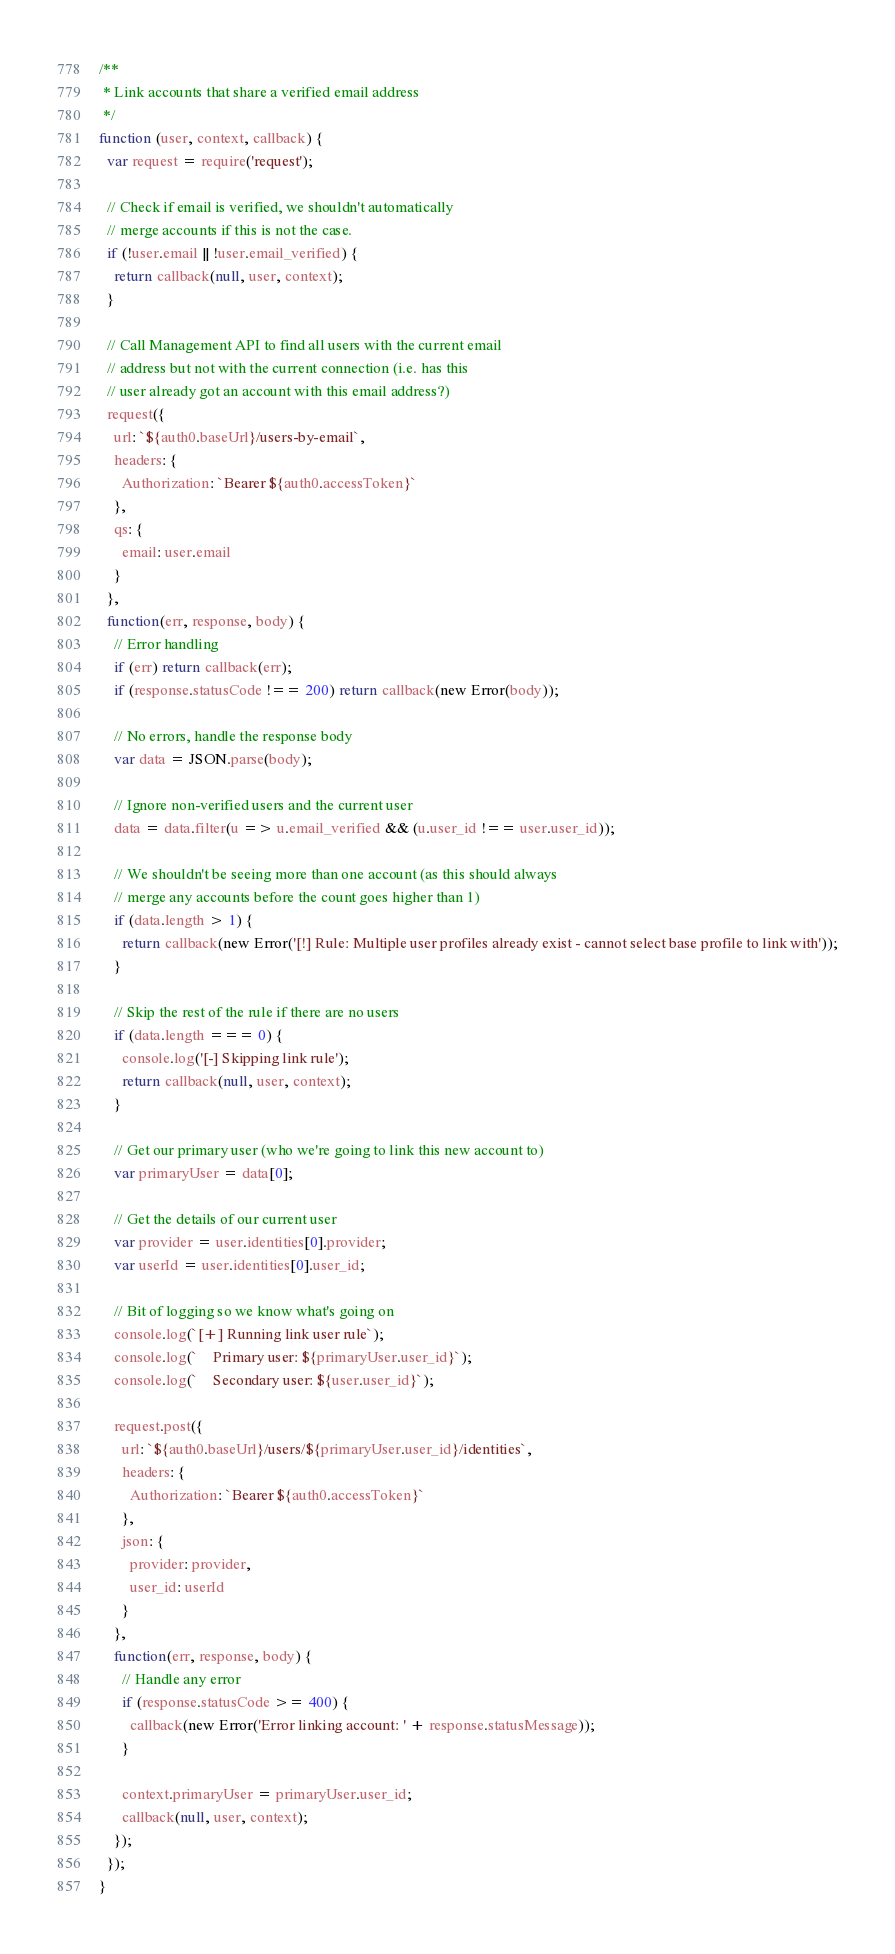<code> <loc_0><loc_0><loc_500><loc_500><_JavaScript_>/**
 * Link accounts that share a verified email address
 */
function (user, context, callback) {
  var request = require('request');

  // Check if email is verified, we shouldn't automatically
  // merge accounts if this is not the case.
  if (!user.email || !user.email_verified) {
    return callback(null, user, context);
  }

  // Call Management API to find all users with the current email
  // address but not with the current connection (i.e. has this
  // user already got an account with this email address?)
  request({
    url: `${auth0.baseUrl}/users-by-email`,
    headers: {
      Authorization: `Bearer ${auth0.accessToken}`
    },
    qs: {
      email: user.email
    }
  },
  function(err, response, body) {
    // Error handling
    if (err) return callback(err);
    if (response.statusCode !== 200) return callback(new Error(body));

    // No errors, handle the response body
    var data = JSON.parse(body);

    // Ignore non-verified users and the current user
    data = data.filter(u => u.email_verified && (u.user_id !== user.user_id));

    // We shouldn't be seeing more than one account (as this should always
    // merge any accounts before the count goes higher than 1)
    if (data.length > 1) {
      return callback(new Error('[!] Rule: Multiple user profiles already exist - cannot select base profile to link with'));
    }

    // Skip the rest of the rule if there are no users
    if (data.length === 0) {
      console.log('[-] Skipping link rule');
      return callback(null, user, context);
    }

    // Get our primary user (who we're going to link this new account to)
    var primaryUser = data[0];

    // Get the details of our current user
    var provider = user.identities[0].provider;
    var userId = user.identities[0].user_id;

    // Bit of logging so we know what's going on
    console.log(`[+] Running link user rule`);
    console.log(`    Primary user: ${primaryUser.user_id}`);
    console.log(`    Secondary user: ${user.user_id}`);

    request.post({
      url: `${auth0.baseUrl}/users/${primaryUser.user_id}/identities`,
      headers: {
        Authorization: `Bearer ${auth0.accessToken}`
      },
      json: {
        provider: provider,
        user_id: userId
      }
    },
    function(err, response, body) {
      // Handle any error
      if (response.statusCode >= 400) {
        callback(new Error('Error linking account: ' + response.statusMessage));
      }

      context.primaryUser = primaryUser.user_id;
      callback(null, user, context);
    });
  });
}
</code> 